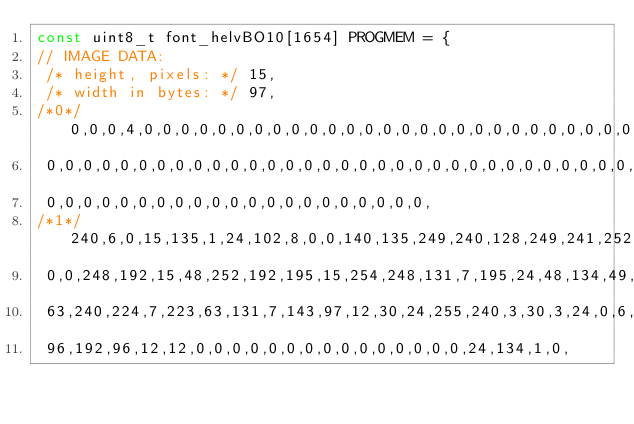<code> <loc_0><loc_0><loc_500><loc_500><_C_>const uint8_t font_helvBO10[1654] PROGMEM = {
// IMAGE DATA:
 /* height, pixels: */ 15,
 /* width in bytes: */ 97,
/*0*/ 0,0,0,4,0,0,0,0,0,0,0,0,0,0,0,0,0,0,0,0,0,0,0,0,0,0,0,0,0,0,0,0,0,0,0,0,0,
 0,0,0,0,0,0,0,0,0,0,0,0,0,0,0,0,0,0,0,0,0,0,0,0,0,0,0,0,0,0,0,0,0,0,0,0,0,0,0,
 0,0,0,0,0,0,0,0,0,0,0,0,0,0,0,0,0,0,0,0,0,
/*1*/ 240,6,0,15,135,1,24,102,8,0,0,140,135,249,240,128,249,241,252,120,120,0,0,
 0,0,248,192,15,48,252,192,195,15,254,248,131,7,195,24,48,134,49,24,48,6,131,7,
 63,240,224,7,223,63,131,7,143,97,12,30,24,255,240,3,30,3,24,0,6,0,128,1,224,0,
 96,192,96,12,12,0,0,0,0,0,0,0,0,0,0,0,0,0,0,0,24,134,1,0,</code> 